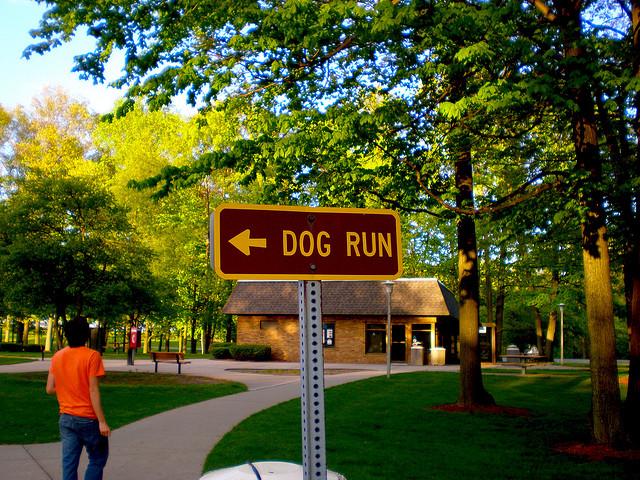Is the sign talking about people?
Keep it brief. No. What is the man walking on?
Short answer required. Sidewalk. What color is the shirt?
Quick response, please. Orange. 